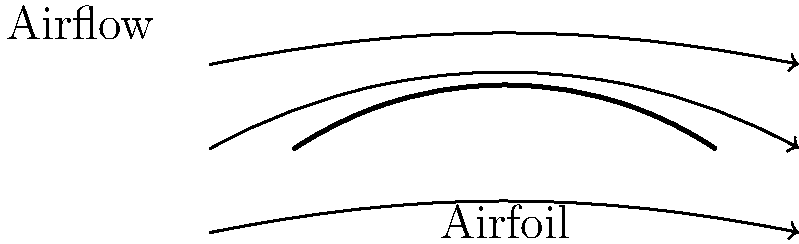As a TV host discussing aerodynamics, you're explaining the concept of lift on an airfoil. Based on the airflow pattern shown in the diagram, what causes the lifting force on the airfoil, and how would you explain this to your audience in an engaging way? To explain the lifting force on an airfoil to a TV audience, we can break it down into these engaging steps:

1. Shape Matters: Notice how the airfoil (wing shape) is curved on top and flatter on the bottom. This special shape is key to creating lift.

2. Air Split: As air approaches the airfoil, it splits. Some goes over the top, some under the bottom.

3. Speed Difference: The air going over the curved top has to travel further than the air going under the flat bottom. To meet up at the back, the top air must move faster.

4. Pressure Difference: Here's where it gets exciting! Faster-moving air creates lower pressure (think of it as thinner air). So, we have lower pressure above the wing and higher pressure below.

5. Lift Creation: Nature loves balance. The higher pressure below pushes up towards the lower pressure above. This upward force is what we call lift!

6. Angle of Attack: The airfoil is also tilted slightly (called the angle of attack), which helps direct more air downwards, further increasing the lifting force.

To make this more relatable, you could use an analogy: "Imagine you're holding two sheets of paper horizontally, then blow between them. The papers will come together because the fast-moving air between them creates lower pressure. An airplane wing works similarly, but with air moving around it instead!"

This explanation combines the scientific principles with a touch of showmanship, perfect for a TV host inspired by Davina McCall's engaging style.
Answer: Pressure difference due to airflow speed variation over curved airfoil surface 